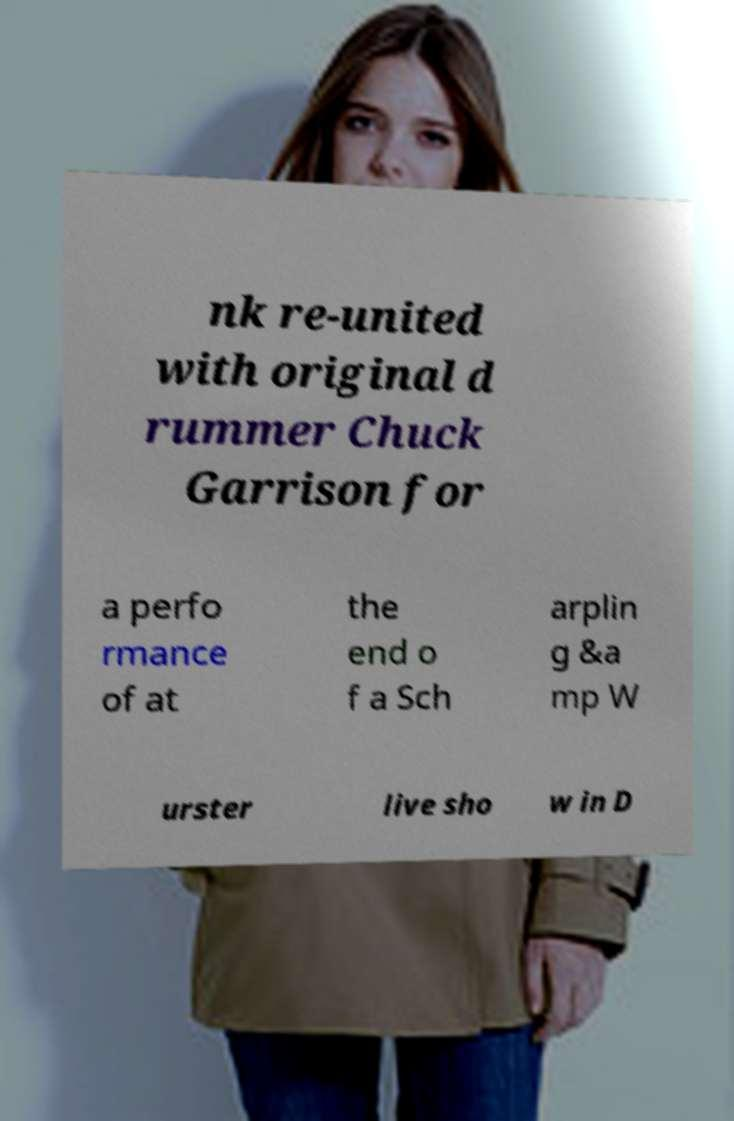Could you assist in decoding the text presented in this image and type it out clearly? nk re-united with original d rummer Chuck Garrison for a perfo rmance of at the end o f a Sch arplin g &a mp W urster live sho w in D 